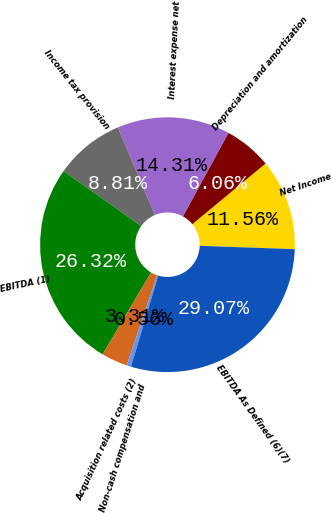Convert chart to OTSL. <chart><loc_0><loc_0><loc_500><loc_500><pie_chart><fcel>Net Income<fcel>Depreciation and amortization<fcel>Interest expense net<fcel>Income tax provision<fcel>EBITDA (1)<fcel>Acquisition related costs (2)<fcel>Non-cash compensation and<fcel>EBITDA As Defined (6)(7)<nl><fcel>11.56%<fcel>6.06%<fcel>14.31%<fcel>8.81%<fcel>26.32%<fcel>3.31%<fcel>0.56%<fcel>29.07%<nl></chart> 